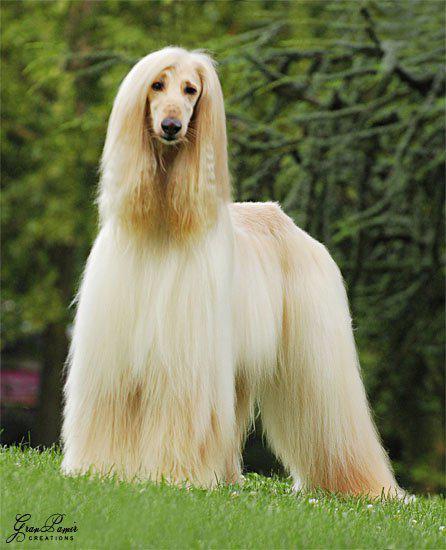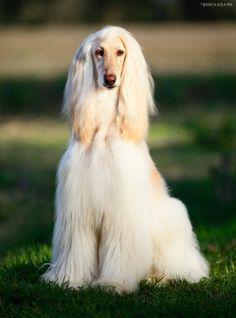The first image is the image on the left, the second image is the image on the right. Analyze the images presented: Is the assertion "An image clearly shows a 'blond' long-haired hound that is on the grass but not standing." valid? Answer yes or no. Yes. The first image is the image on the left, the second image is the image on the right. Analyze the images presented: Is the assertion "The dog in the image on the left is taking strides as it walks outside." valid? Answer yes or no. No. 